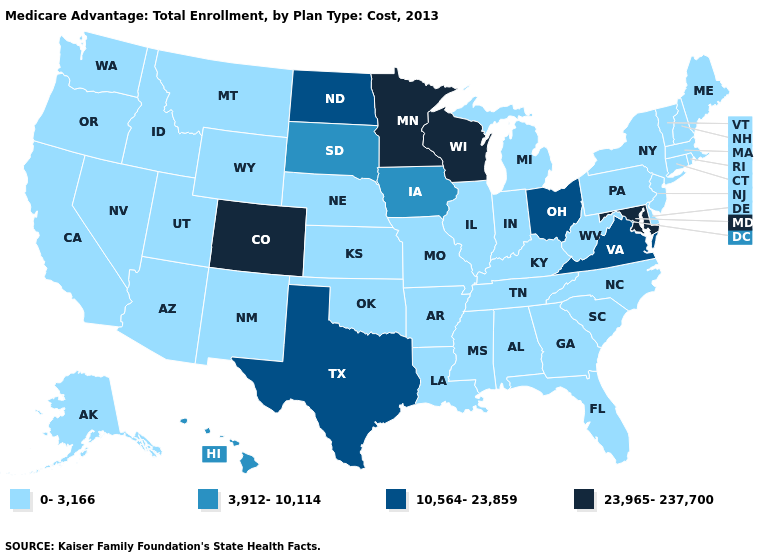What is the value of Maine?
Be succinct. 0-3,166. What is the value of Illinois?
Answer briefly. 0-3,166. Among the states that border Georgia , which have the lowest value?
Keep it brief. Alabama, Florida, North Carolina, South Carolina, Tennessee. Among the states that border Nevada , which have the highest value?
Short answer required. Arizona, California, Idaho, Oregon, Utah. What is the value of Florida?
Concise answer only. 0-3,166. Does the map have missing data?
Write a very short answer. No. What is the highest value in states that border New Mexico?
Give a very brief answer. 23,965-237,700. Which states have the lowest value in the MidWest?
Concise answer only. Illinois, Indiana, Kansas, Michigan, Missouri, Nebraska. What is the value of Wyoming?
Give a very brief answer. 0-3,166. What is the lowest value in the USA?
Be succinct. 0-3,166. What is the lowest value in states that border Virginia?
Be succinct. 0-3,166. What is the value of Nevada?
Keep it brief. 0-3,166. Which states have the lowest value in the MidWest?
Short answer required. Illinois, Indiana, Kansas, Michigan, Missouri, Nebraska. What is the value of Wyoming?
Keep it brief. 0-3,166. 